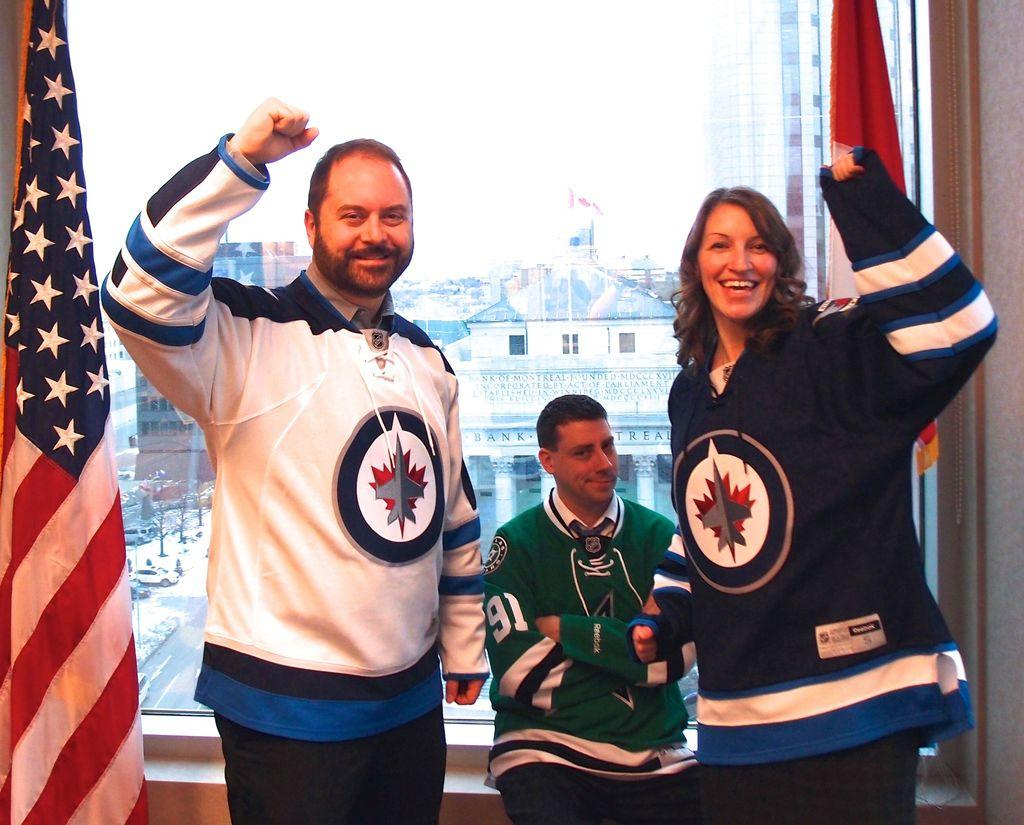<image>
Share a concise interpretation of the image provided. The building in the background is shown to be a Bank. 